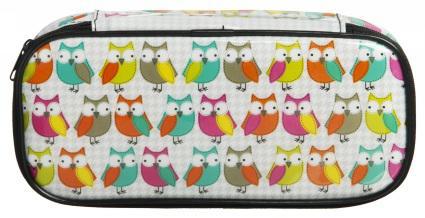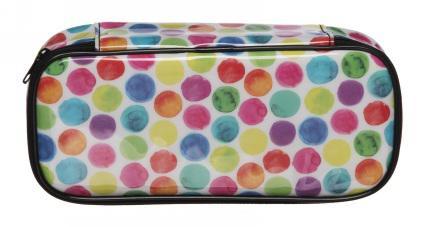The first image is the image on the left, the second image is the image on the right. For the images shown, is this caption "There is a bag with a multi-colored polka dot pattern on it." true? Answer yes or no. Yes. 